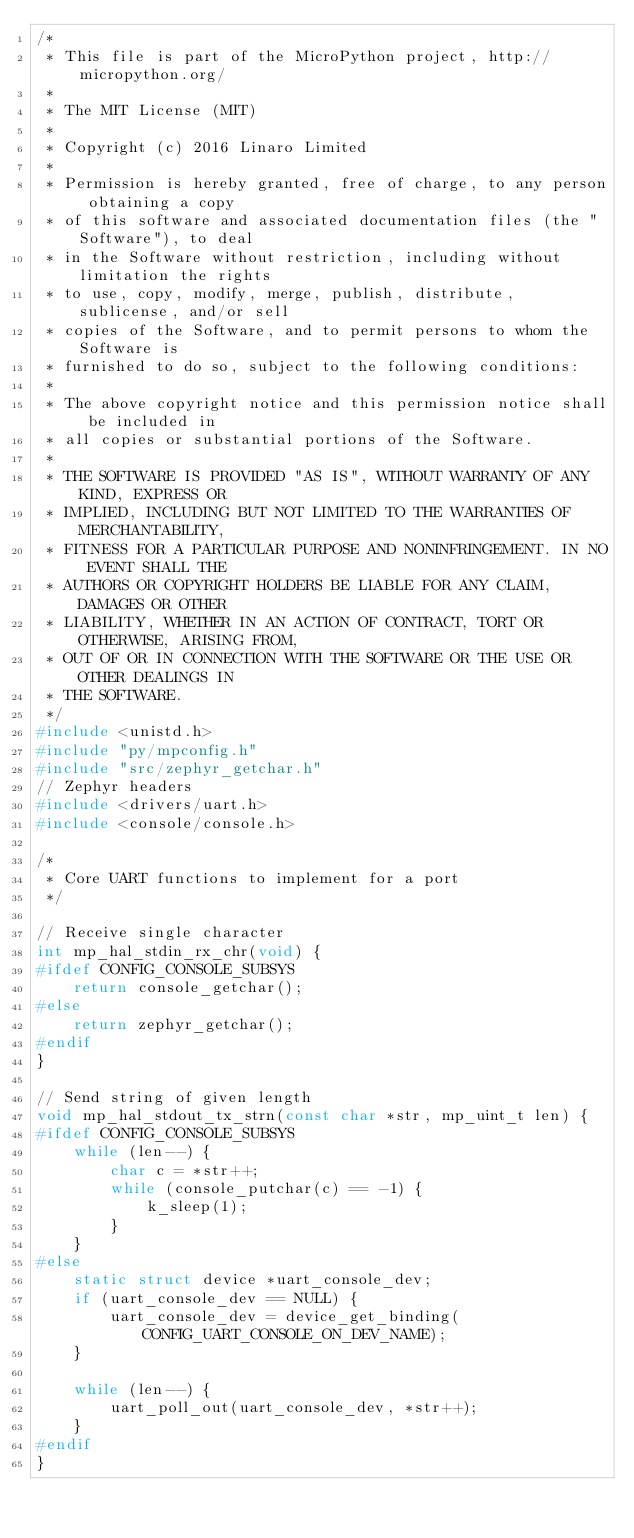<code> <loc_0><loc_0><loc_500><loc_500><_C_>/*
 * This file is part of the MicroPython project, http://micropython.org/
 *
 * The MIT License (MIT)
 *
 * Copyright (c) 2016 Linaro Limited
 *
 * Permission is hereby granted, free of charge, to any person obtaining a copy
 * of this software and associated documentation files (the "Software"), to deal
 * in the Software without restriction, including without limitation the rights
 * to use, copy, modify, merge, publish, distribute, sublicense, and/or sell
 * copies of the Software, and to permit persons to whom the Software is
 * furnished to do so, subject to the following conditions:
 *
 * The above copyright notice and this permission notice shall be included in
 * all copies or substantial portions of the Software.
 *
 * THE SOFTWARE IS PROVIDED "AS IS", WITHOUT WARRANTY OF ANY KIND, EXPRESS OR
 * IMPLIED, INCLUDING BUT NOT LIMITED TO THE WARRANTIES OF MERCHANTABILITY,
 * FITNESS FOR A PARTICULAR PURPOSE AND NONINFRINGEMENT. IN NO EVENT SHALL THE
 * AUTHORS OR COPYRIGHT HOLDERS BE LIABLE FOR ANY CLAIM, DAMAGES OR OTHER
 * LIABILITY, WHETHER IN AN ACTION OF CONTRACT, TORT OR OTHERWISE, ARISING FROM,
 * OUT OF OR IN CONNECTION WITH THE SOFTWARE OR THE USE OR OTHER DEALINGS IN
 * THE SOFTWARE.
 */
#include <unistd.h>
#include "py/mpconfig.h"
#include "src/zephyr_getchar.h"
// Zephyr headers
#include <drivers/uart.h>
#include <console/console.h>

/*
 * Core UART functions to implement for a port
 */

// Receive single character
int mp_hal_stdin_rx_chr(void) {
#ifdef CONFIG_CONSOLE_SUBSYS
    return console_getchar();
#else
    return zephyr_getchar();
#endif
}

// Send string of given length
void mp_hal_stdout_tx_strn(const char *str, mp_uint_t len) {
#ifdef CONFIG_CONSOLE_SUBSYS
    while (len--) {
        char c = *str++;
        while (console_putchar(c) == -1) {
            k_sleep(1);
        }
    }
#else
    static struct device *uart_console_dev;
    if (uart_console_dev == NULL) {
        uart_console_dev = device_get_binding(CONFIG_UART_CONSOLE_ON_DEV_NAME);
    }

    while (len--) {
        uart_poll_out(uart_console_dev, *str++);
    }
#endif
}
</code> 